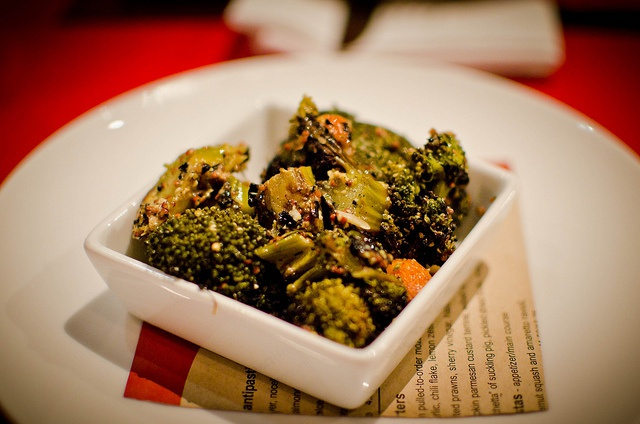Describe the objects in this image and their specific colors. I can see bowl in black, tan, and olive tones, dining table in black, maroon, and brown tones, broccoli in black, olive, and maroon tones, broccoli in black, olive, and maroon tones, and broccoli in black, olive, and orange tones in this image. 